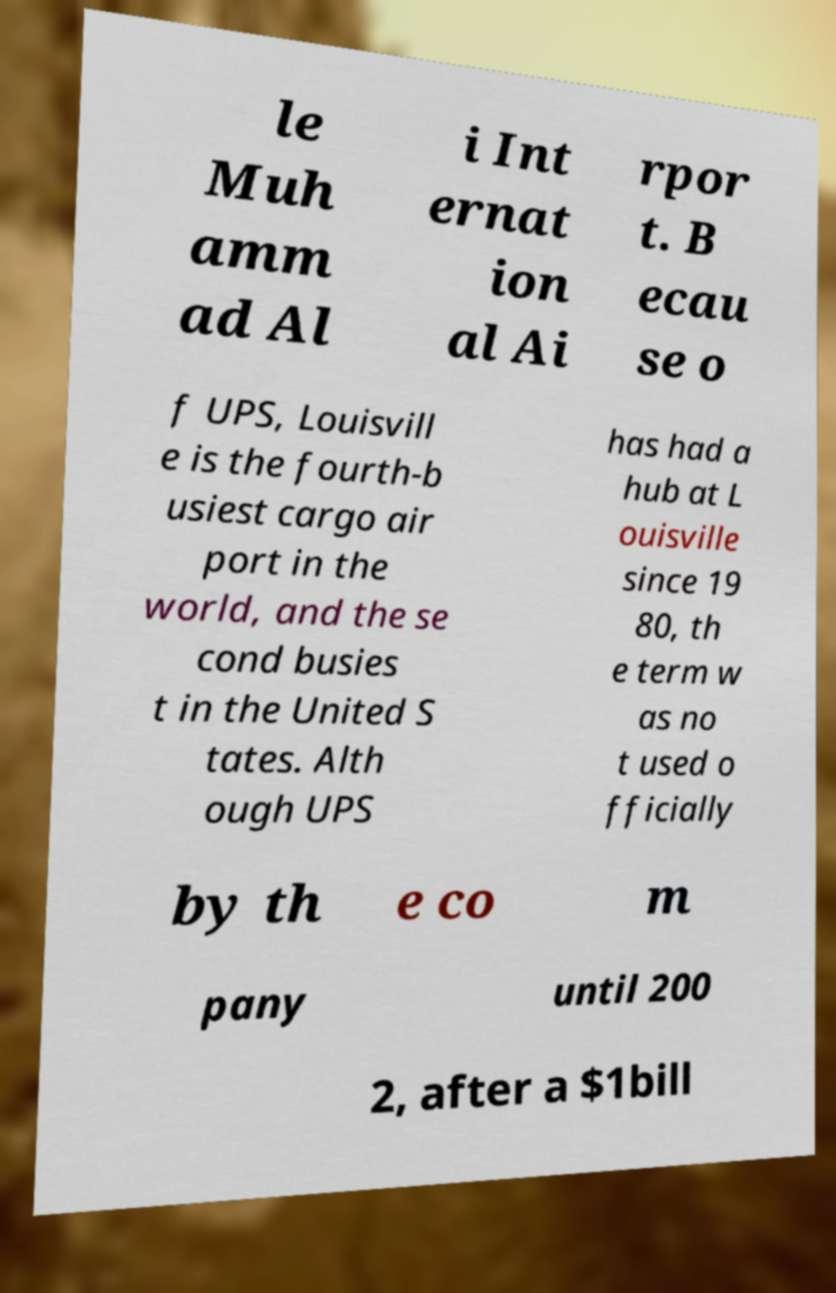There's text embedded in this image that I need extracted. Can you transcribe it verbatim? le Muh amm ad Al i Int ernat ion al Ai rpor t. B ecau se o f UPS, Louisvill e is the fourth-b usiest cargo air port in the world, and the se cond busies t in the United S tates. Alth ough UPS has had a hub at L ouisville since 19 80, th e term w as no t used o fficially by th e co m pany until 200 2, after a $1bill 